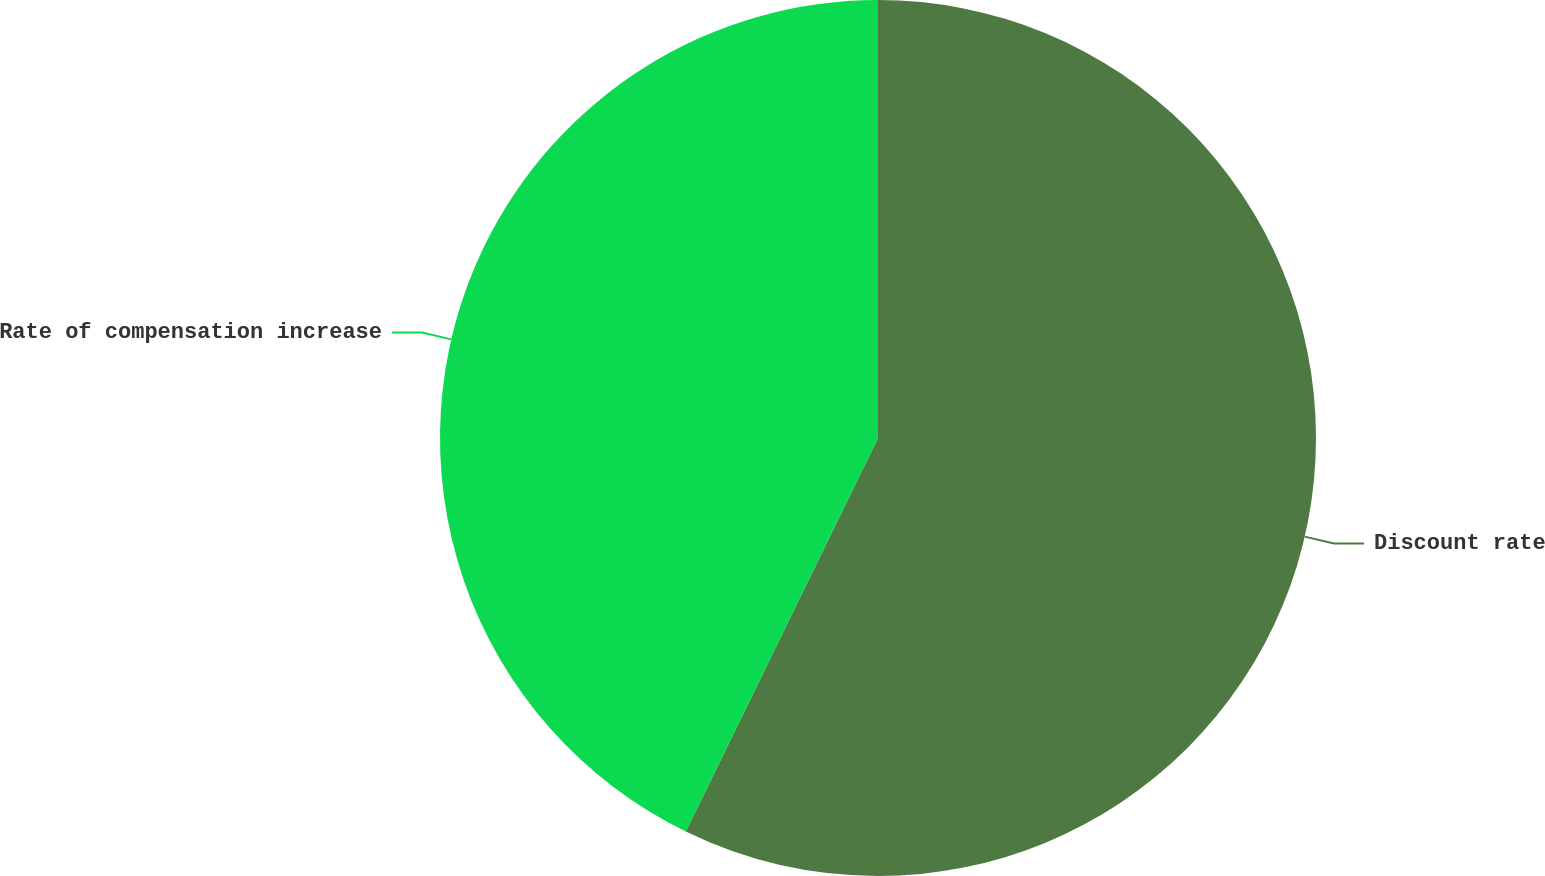Convert chart to OTSL. <chart><loc_0><loc_0><loc_500><loc_500><pie_chart><fcel>Discount rate<fcel>Rate of compensation increase<nl><fcel>57.23%<fcel>42.77%<nl></chart> 